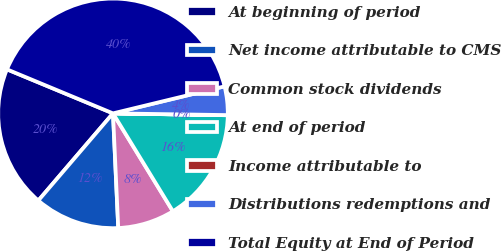<chart> <loc_0><loc_0><loc_500><loc_500><pie_chart><fcel>At beginning of period<fcel>Net income attributable to CMS<fcel>Common stock dividends<fcel>At end of period<fcel>Income attributable to<fcel>Distributions redemptions and<fcel>Total Equity at End of Period<nl><fcel>19.99%<fcel>12.0%<fcel>8.01%<fcel>16.0%<fcel>0.02%<fcel>4.02%<fcel>39.96%<nl></chart> 